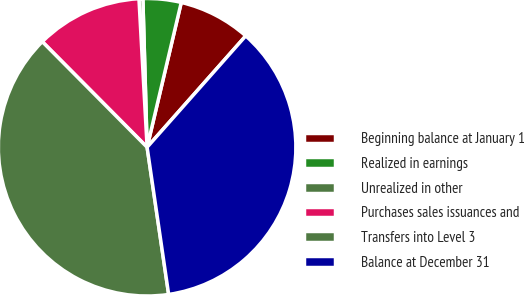Convert chart. <chart><loc_0><loc_0><loc_500><loc_500><pie_chart><fcel>Beginning balance at January 1<fcel>Realized in earnings<fcel>Unrealized in other<fcel>Purchases sales issuances and<fcel>Transfers into Level 3<fcel>Balance at December 31<nl><fcel>7.85%<fcel>4.14%<fcel>0.42%<fcel>11.57%<fcel>39.87%<fcel>36.15%<nl></chart> 